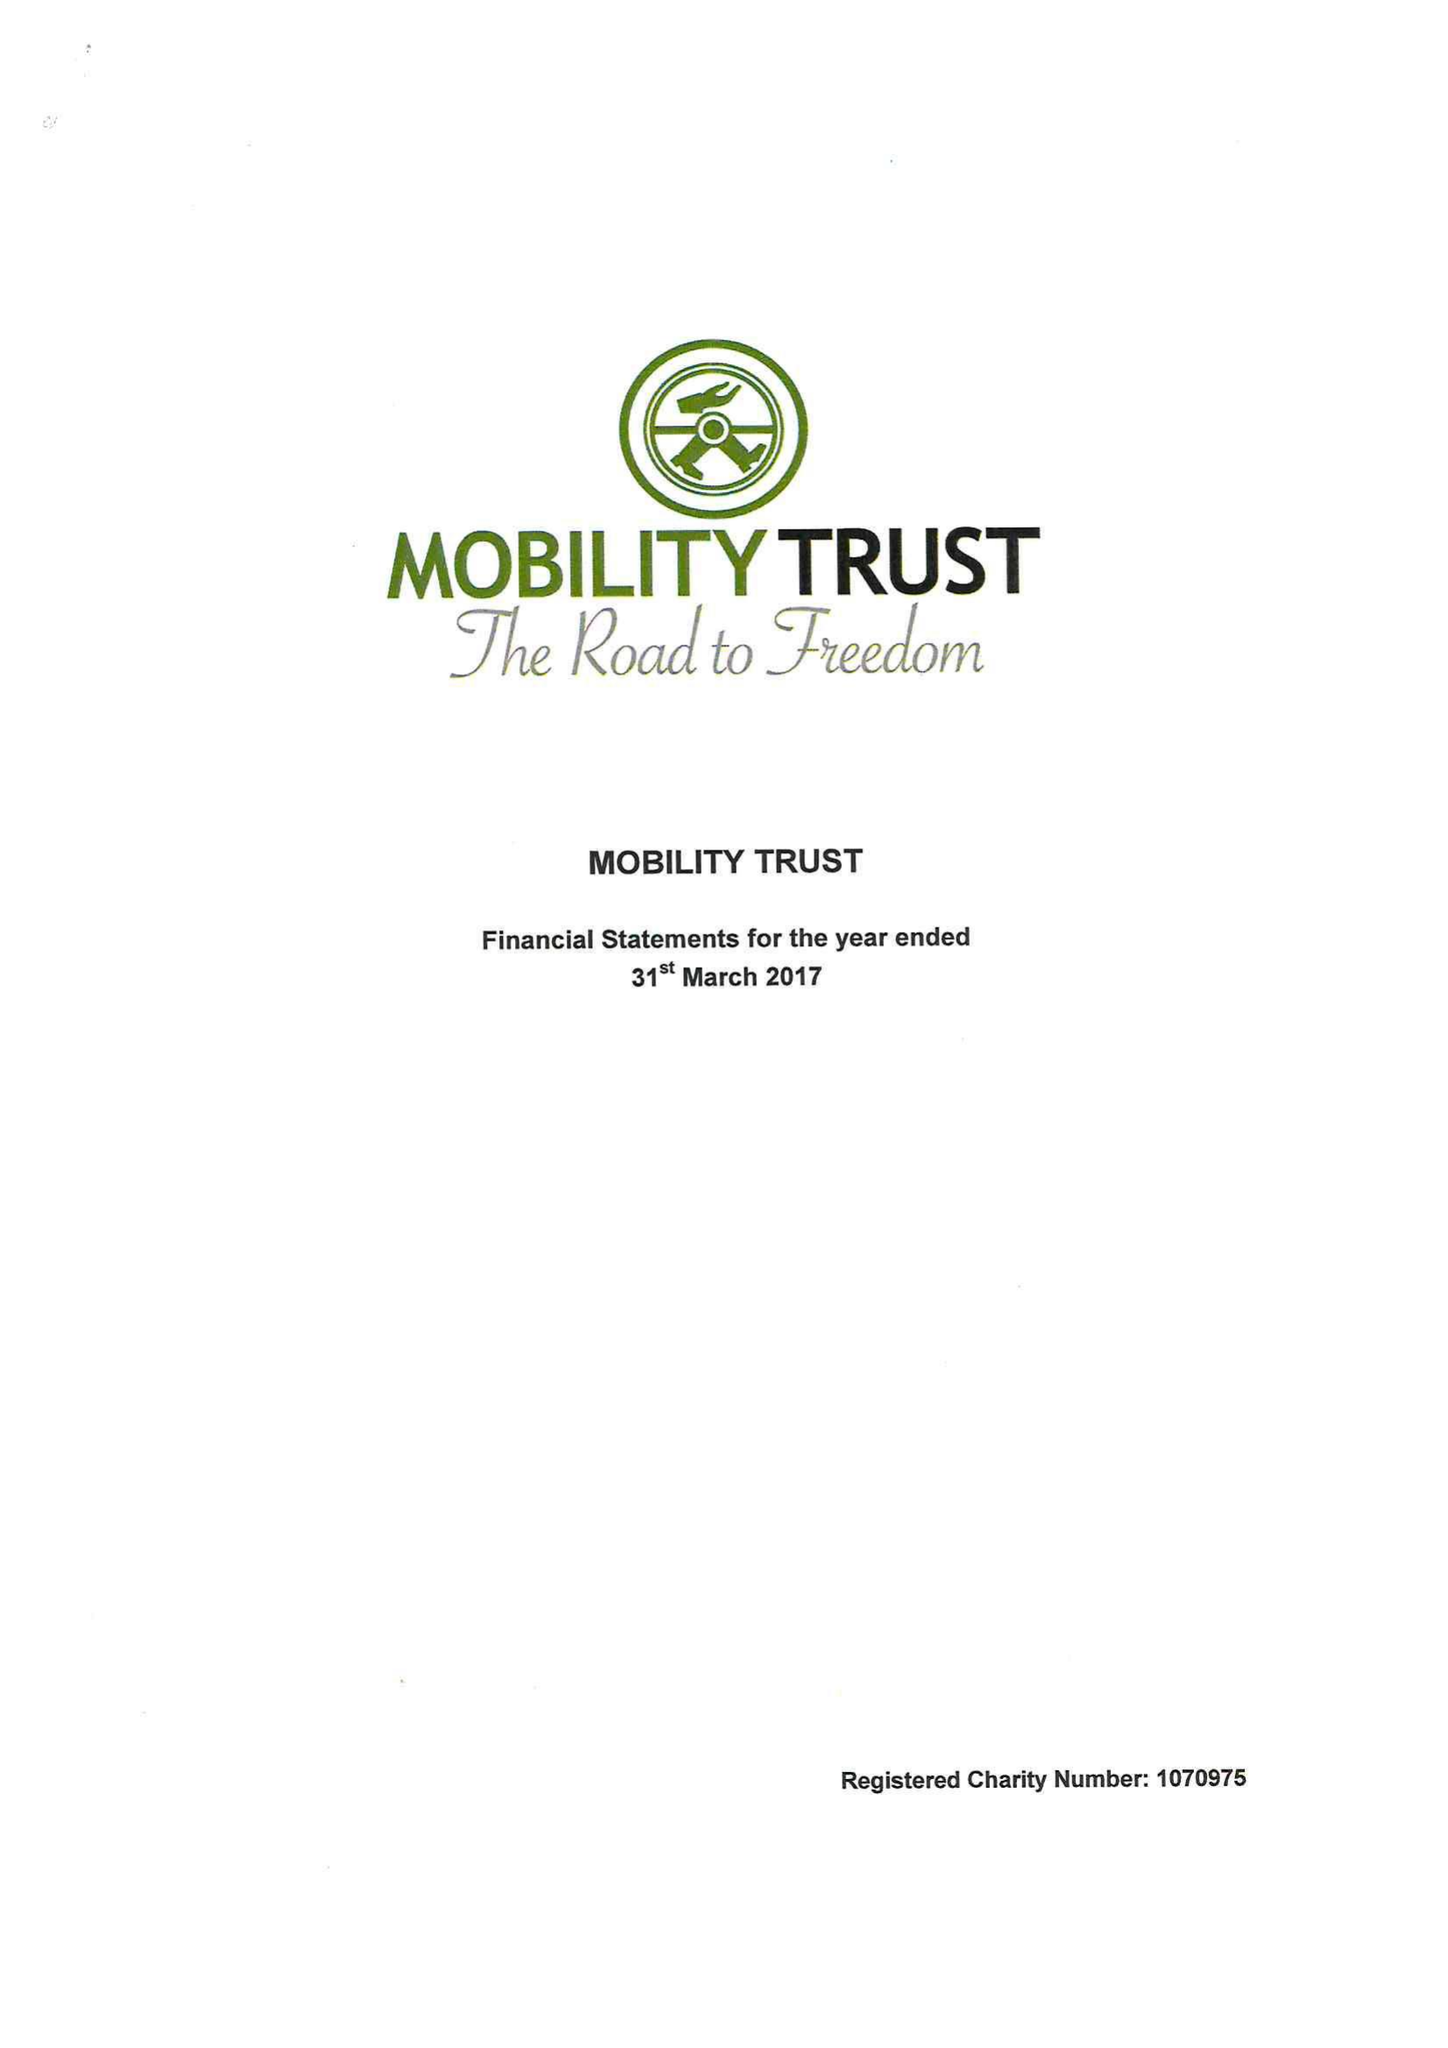What is the value for the charity_name?
Answer the question using a single word or phrase. Mobility Trust Ii 